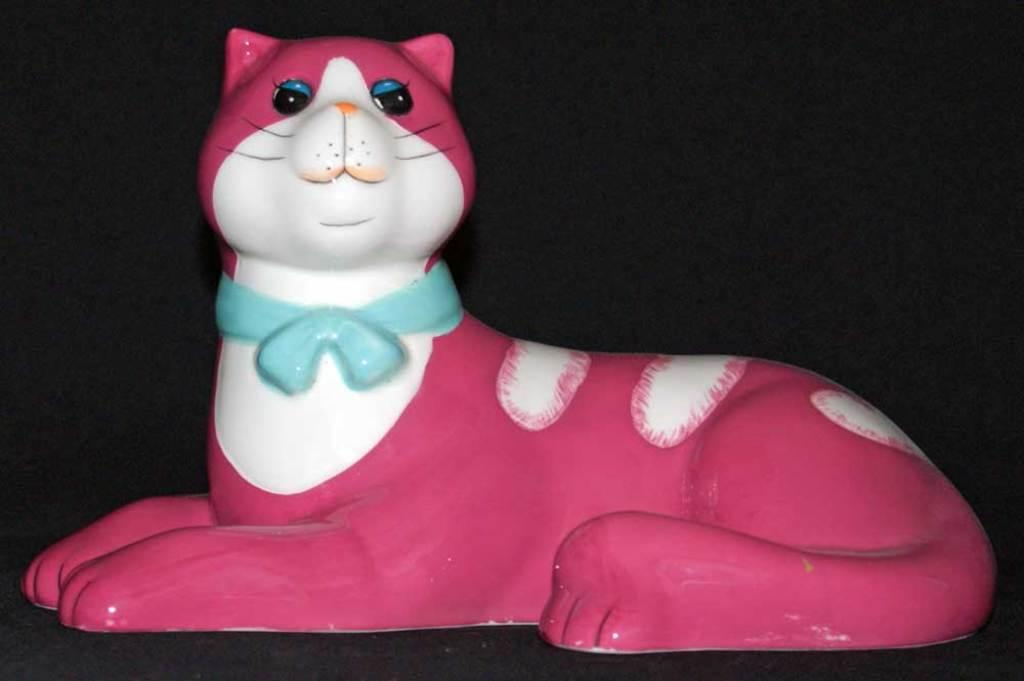What is the main subject of the image? There is a sculpture of a cat in the image. Can you describe the colors of the cat sculpture? The cat sculpture has a pink, white, and blue color. What color is present in the background of the image? There is a black color in the background of the image. How many pickles are on the cat sculpture in the image? There are no pickles present on the cat sculpture in the image. 